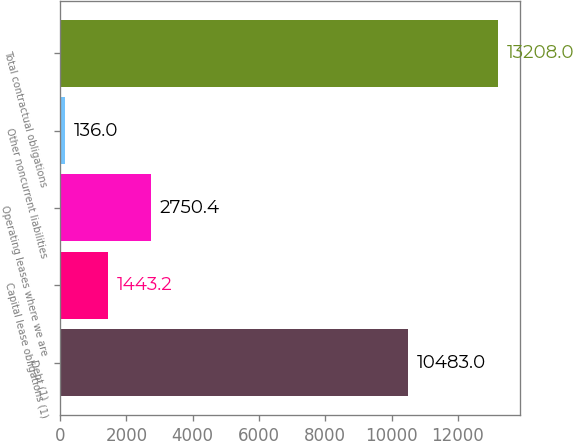<chart> <loc_0><loc_0><loc_500><loc_500><bar_chart><fcel>Debt (1)<fcel>Capital lease obligations (1)<fcel>Operating leases where we are<fcel>Other noncurrent liabilities<fcel>Total contractual obligations<nl><fcel>10483<fcel>1443.2<fcel>2750.4<fcel>136<fcel>13208<nl></chart> 